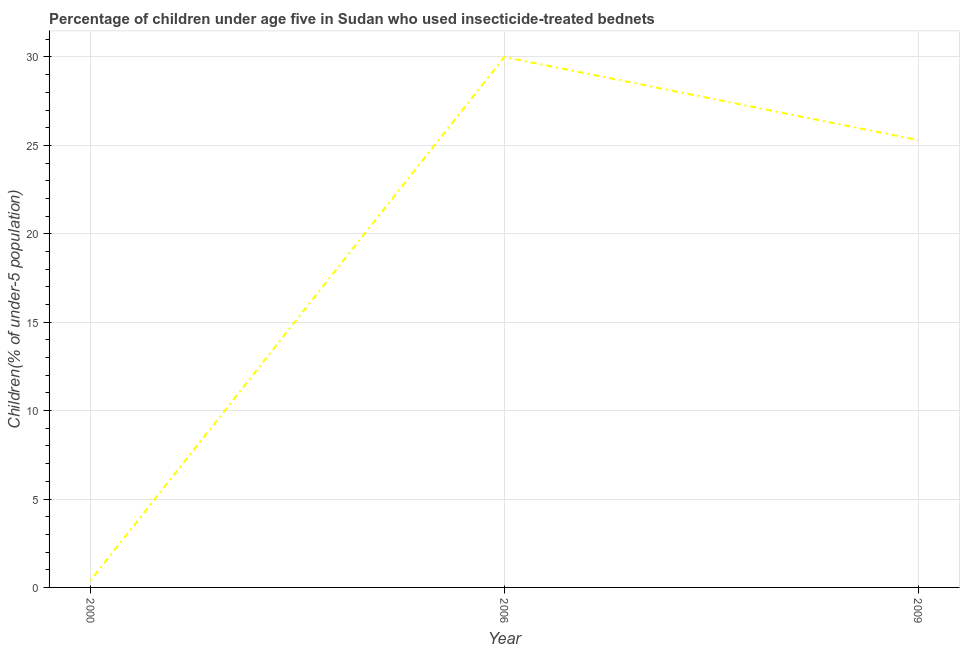Across all years, what is the maximum percentage of children who use of insecticide-treated bed nets?
Ensure brevity in your answer.  30. Across all years, what is the minimum percentage of children who use of insecticide-treated bed nets?
Provide a short and direct response. 0.4. What is the sum of the percentage of children who use of insecticide-treated bed nets?
Your answer should be compact. 55.7. What is the difference between the percentage of children who use of insecticide-treated bed nets in 2000 and 2009?
Provide a short and direct response. -24.9. What is the average percentage of children who use of insecticide-treated bed nets per year?
Give a very brief answer. 18.57. What is the median percentage of children who use of insecticide-treated bed nets?
Provide a succinct answer. 25.3. In how many years, is the percentage of children who use of insecticide-treated bed nets greater than 22 %?
Provide a succinct answer. 2. Do a majority of the years between 2009 and 2000 (inclusive) have percentage of children who use of insecticide-treated bed nets greater than 2 %?
Offer a very short reply. No. What is the ratio of the percentage of children who use of insecticide-treated bed nets in 2000 to that in 2006?
Provide a succinct answer. 0.01. Is the percentage of children who use of insecticide-treated bed nets in 2006 less than that in 2009?
Ensure brevity in your answer.  No. Is the difference between the percentage of children who use of insecticide-treated bed nets in 2000 and 2009 greater than the difference between any two years?
Your answer should be compact. No. What is the difference between the highest and the second highest percentage of children who use of insecticide-treated bed nets?
Provide a short and direct response. 4.7. What is the difference between the highest and the lowest percentage of children who use of insecticide-treated bed nets?
Keep it short and to the point. 29.6. Does the percentage of children who use of insecticide-treated bed nets monotonically increase over the years?
Make the answer very short. No. How many lines are there?
Your response must be concise. 1. Does the graph contain any zero values?
Ensure brevity in your answer.  No. Does the graph contain grids?
Ensure brevity in your answer.  Yes. What is the title of the graph?
Make the answer very short. Percentage of children under age five in Sudan who used insecticide-treated bednets. What is the label or title of the X-axis?
Make the answer very short. Year. What is the label or title of the Y-axis?
Ensure brevity in your answer.  Children(% of under-5 population). What is the Children(% of under-5 population) in 2000?
Offer a very short reply. 0.4. What is the Children(% of under-5 population) in 2009?
Your answer should be very brief. 25.3. What is the difference between the Children(% of under-5 population) in 2000 and 2006?
Keep it short and to the point. -29.6. What is the difference between the Children(% of under-5 population) in 2000 and 2009?
Your answer should be very brief. -24.9. What is the difference between the Children(% of under-5 population) in 2006 and 2009?
Provide a succinct answer. 4.7. What is the ratio of the Children(% of under-5 population) in 2000 to that in 2006?
Offer a very short reply. 0.01. What is the ratio of the Children(% of under-5 population) in 2000 to that in 2009?
Ensure brevity in your answer.  0.02. What is the ratio of the Children(% of under-5 population) in 2006 to that in 2009?
Give a very brief answer. 1.19. 